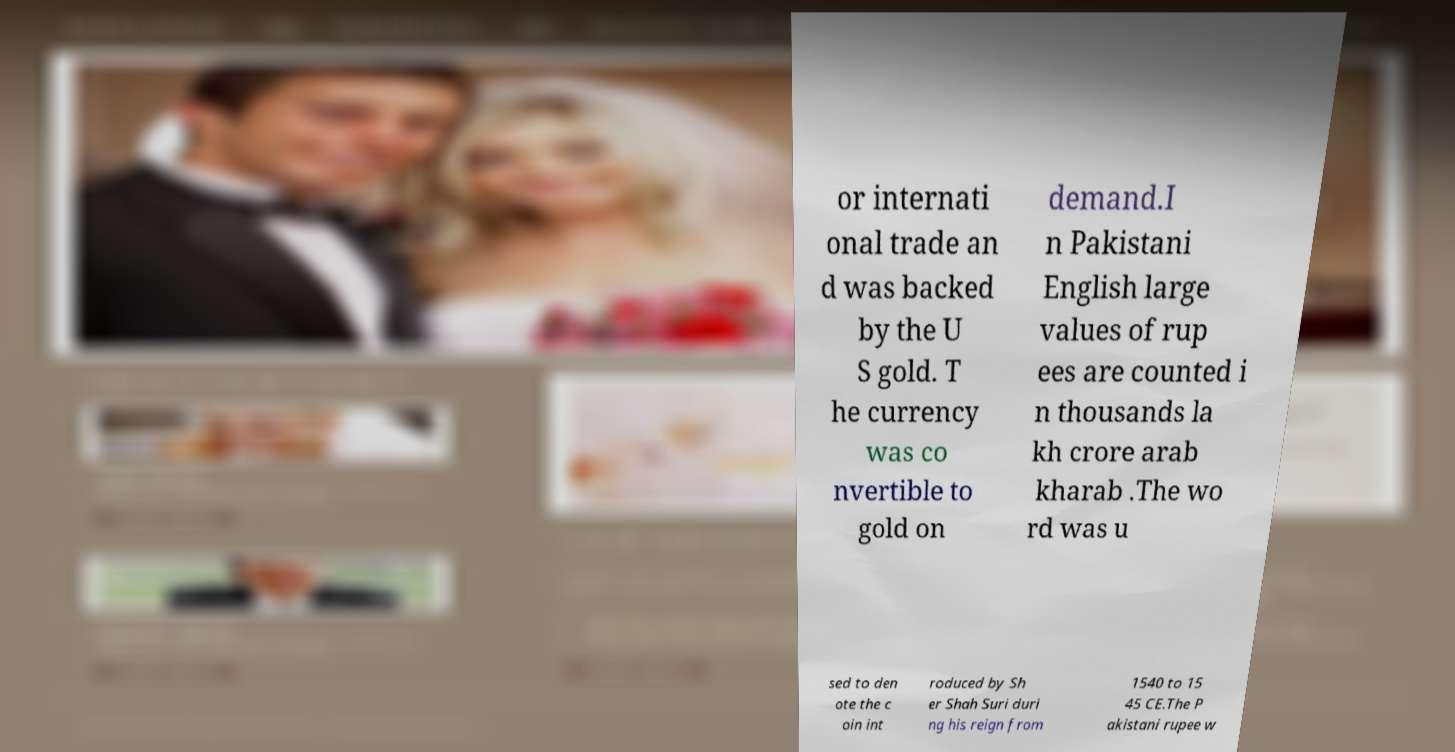Could you extract and type out the text from this image? or internati onal trade an d was backed by the U S gold. T he currency was co nvertible to gold on demand.I n Pakistani English large values of rup ees are counted i n thousands la kh crore arab kharab .The wo rd was u sed to den ote the c oin int roduced by Sh er Shah Suri duri ng his reign from 1540 to 15 45 CE.The P akistani rupee w 